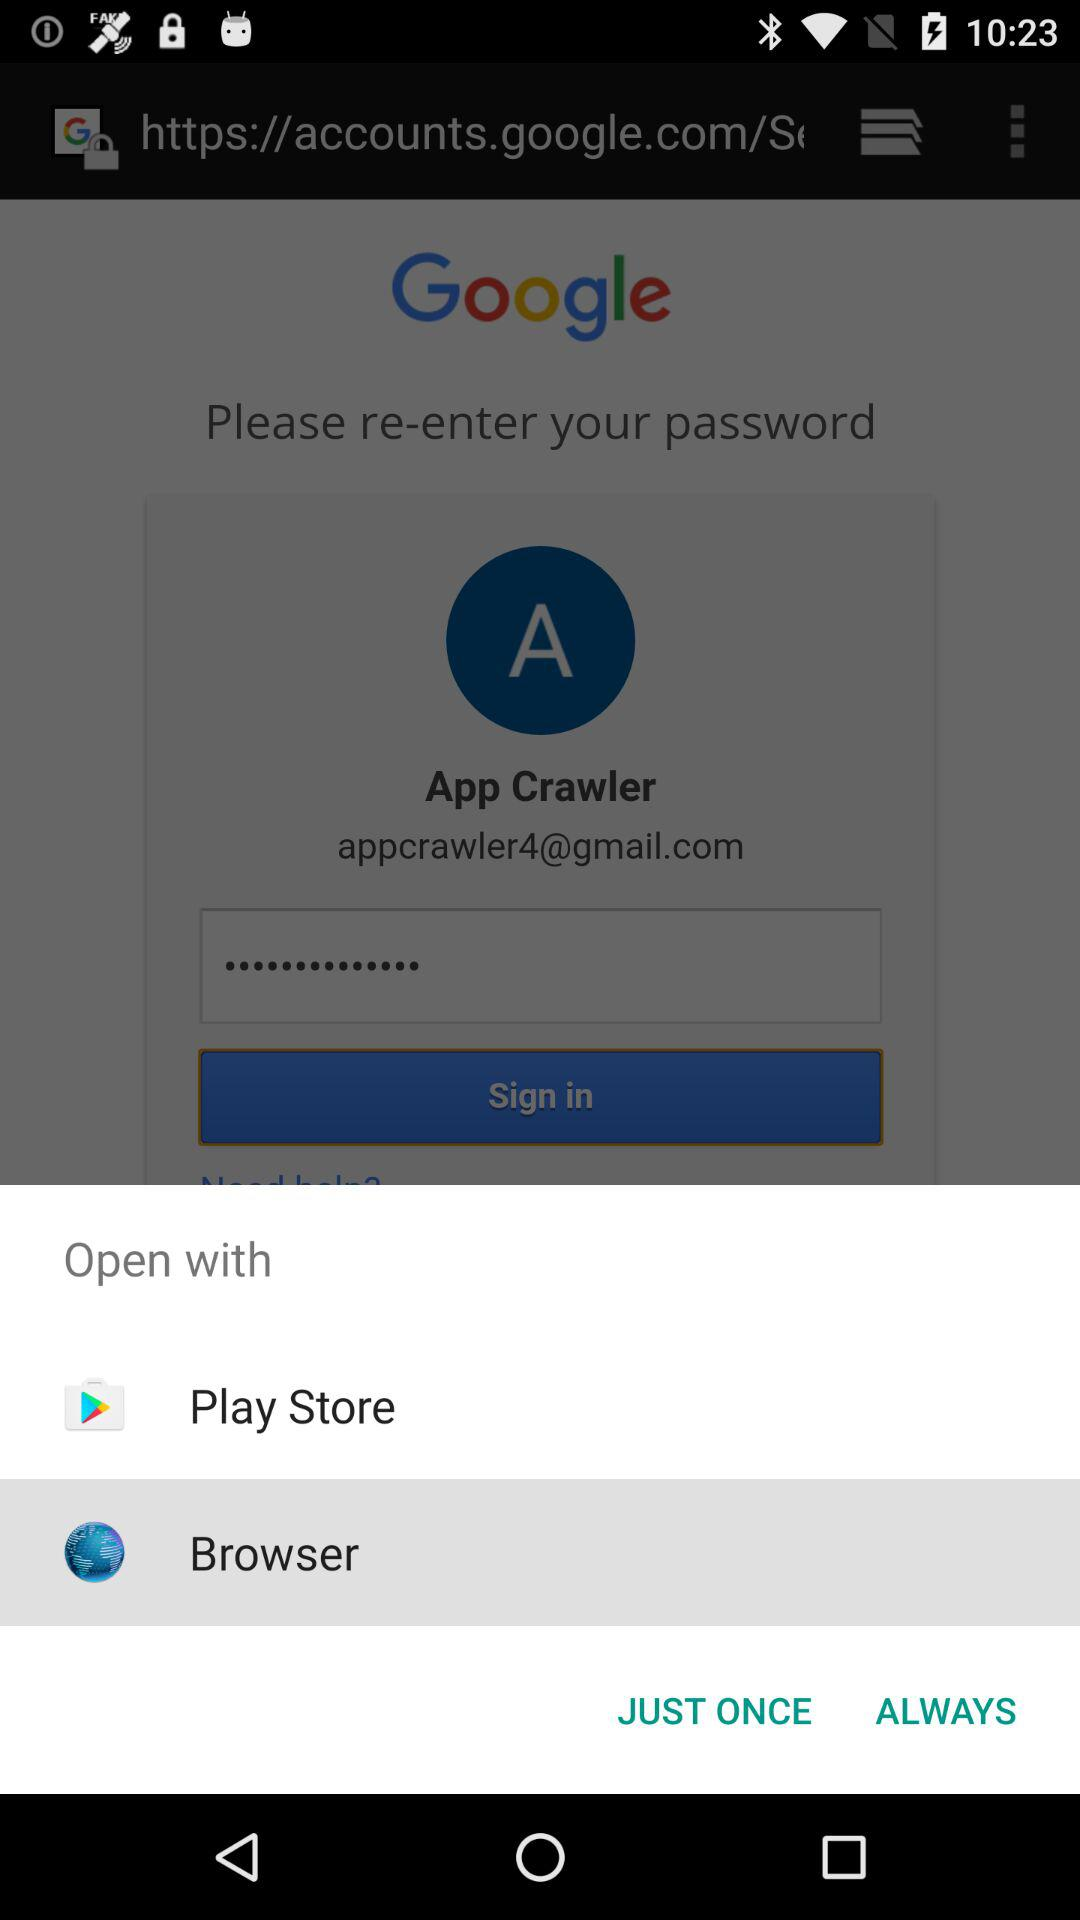Through which applications can we open it? You can open it through "Play Store" and "Browser". 